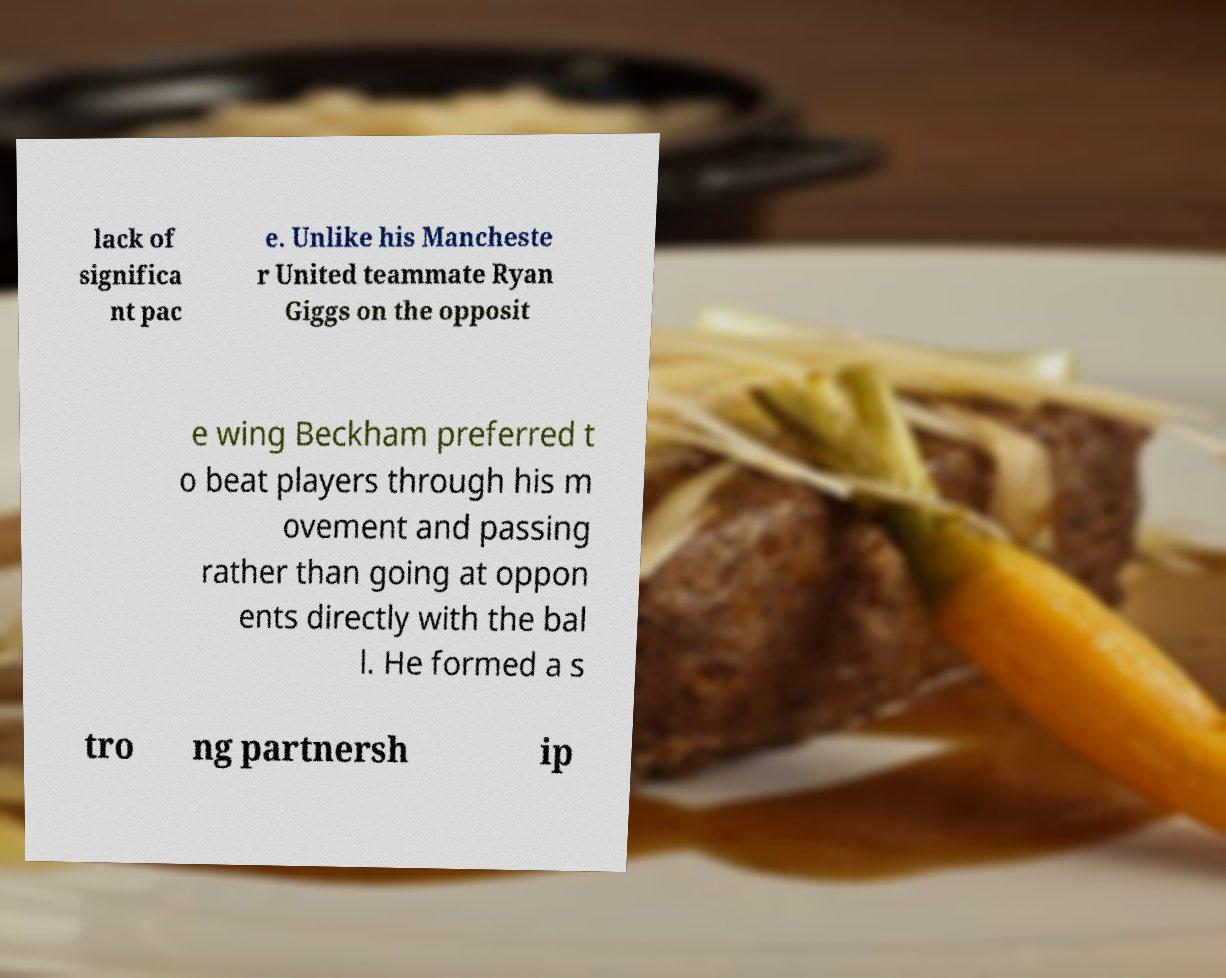There's text embedded in this image that I need extracted. Can you transcribe it verbatim? lack of significa nt pac e. Unlike his Mancheste r United teammate Ryan Giggs on the opposit e wing Beckham preferred t o beat players through his m ovement and passing rather than going at oppon ents directly with the bal l. He formed a s tro ng partnersh ip 